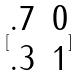Convert formula to latex. <formula><loc_0><loc_0><loc_500><loc_500>[ \begin{matrix} . 7 & 0 \\ . 3 & 1 \end{matrix} ]</formula> 